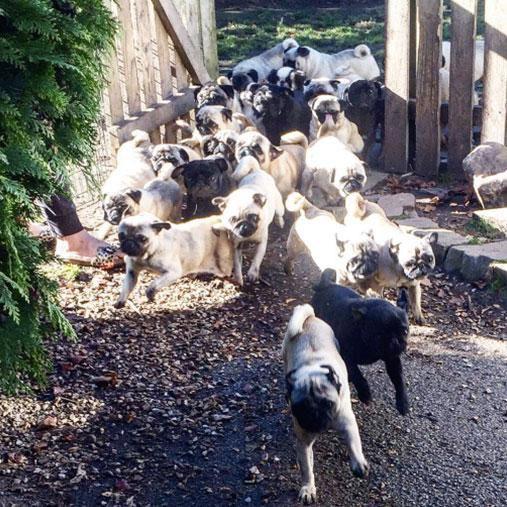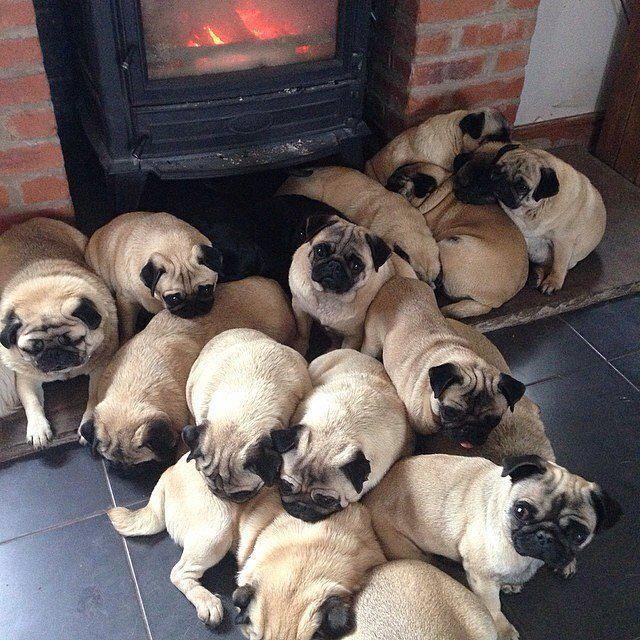The first image is the image on the left, the second image is the image on the right. Assess this claim about the two images: "Pugs are huddled together on a gray tiled floor". Correct or not? Answer yes or no. Yes. 